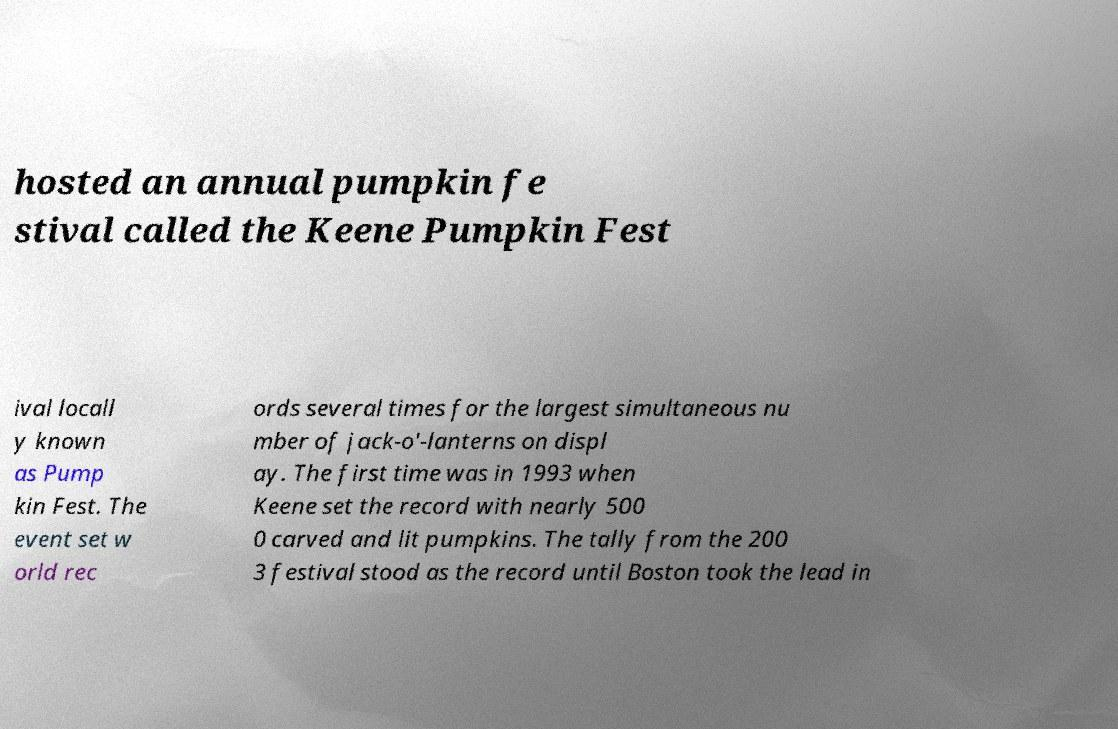Could you assist in decoding the text presented in this image and type it out clearly? hosted an annual pumpkin fe stival called the Keene Pumpkin Fest ival locall y known as Pump kin Fest. The event set w orld rec ords several times for the largest simultaneous nu mber of jack-o'-lanterns on displ ay. The first time was in 1993 when Keene set the record with nearly 500 0 carved and lit pumpkins. The tally from the 200 3 festival stood as the record until Boston took the lead in 